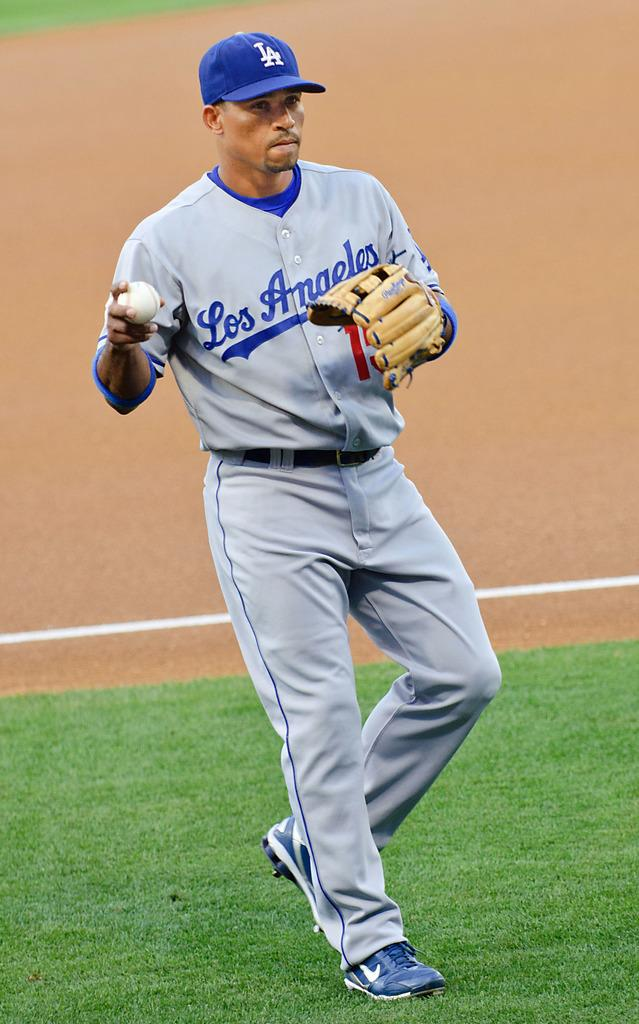<image>
Present a compact description of the photo's key features. Los Angeles baseball player holding a baseball near one of the bases. 